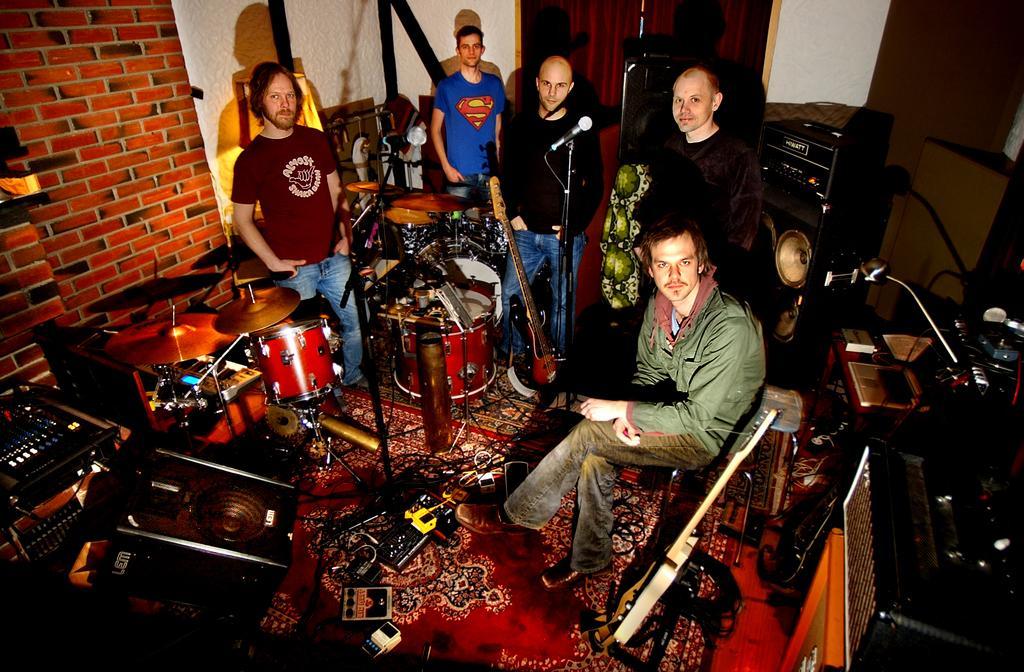Could you give a brief overview of what you see in this image? Here we can see five person among them one person is sitting and rest of the person were standing. In front of them they were some musical instruments. Here there is a microphone and back of them there is a brick wall. 